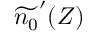Convert formula to latex. <formula><loc_0><loc_0><loc_500><loc_500>\widetilde { n _ { 0 } } ^ { \prime } ( Z )</formula> 